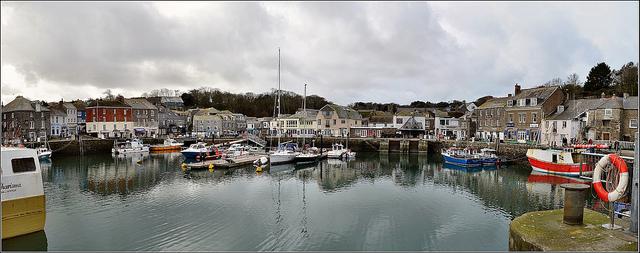Is the building on the right a hotel?
Write a very short answer. Yes. Where is the life preserver?
Answer briefly. Right. Can you swim here?
Give a very brief answer. No. 